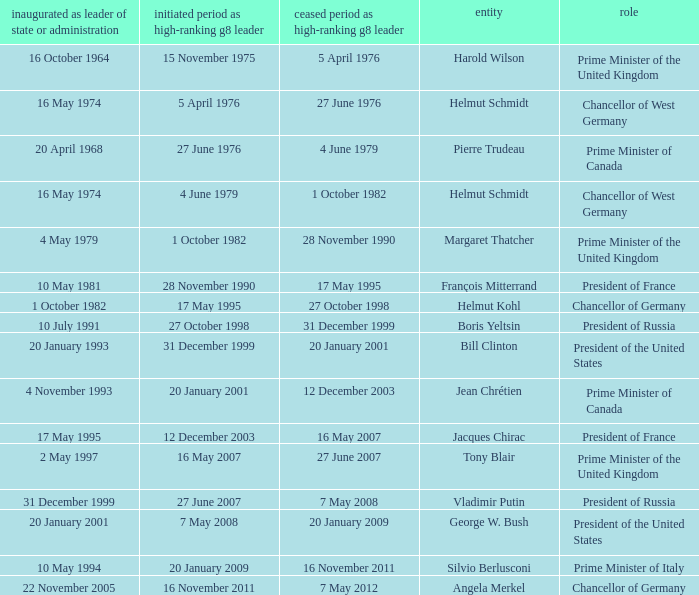When did the Prime Minister of Italy take office? 10 May 1994. 